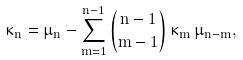<formula> <loc_0><loc_0><loc_500><loc_500>\kappa _ { n } = \mu _ { n } - \sum _ { m = 1 } ^ { n - 1 } \binom { n - 1 } { m - 1 } \, \kappa _ { m } \, \mu _ { n - m } ,</formula> 